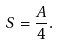Convert formula to latex. <formula><loc_0><loc_0><loc_500><loc_500>S = \frac { A } { 4 } .</formula> 